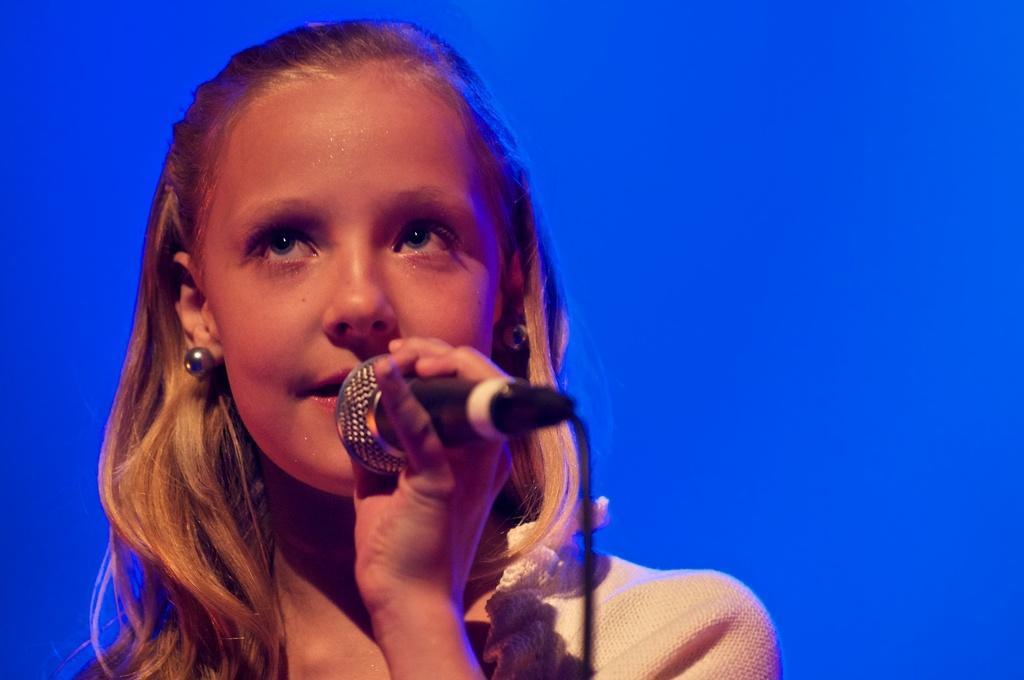Describe this image in one or two sentences. There is a girl in the picture holding a microphone. 